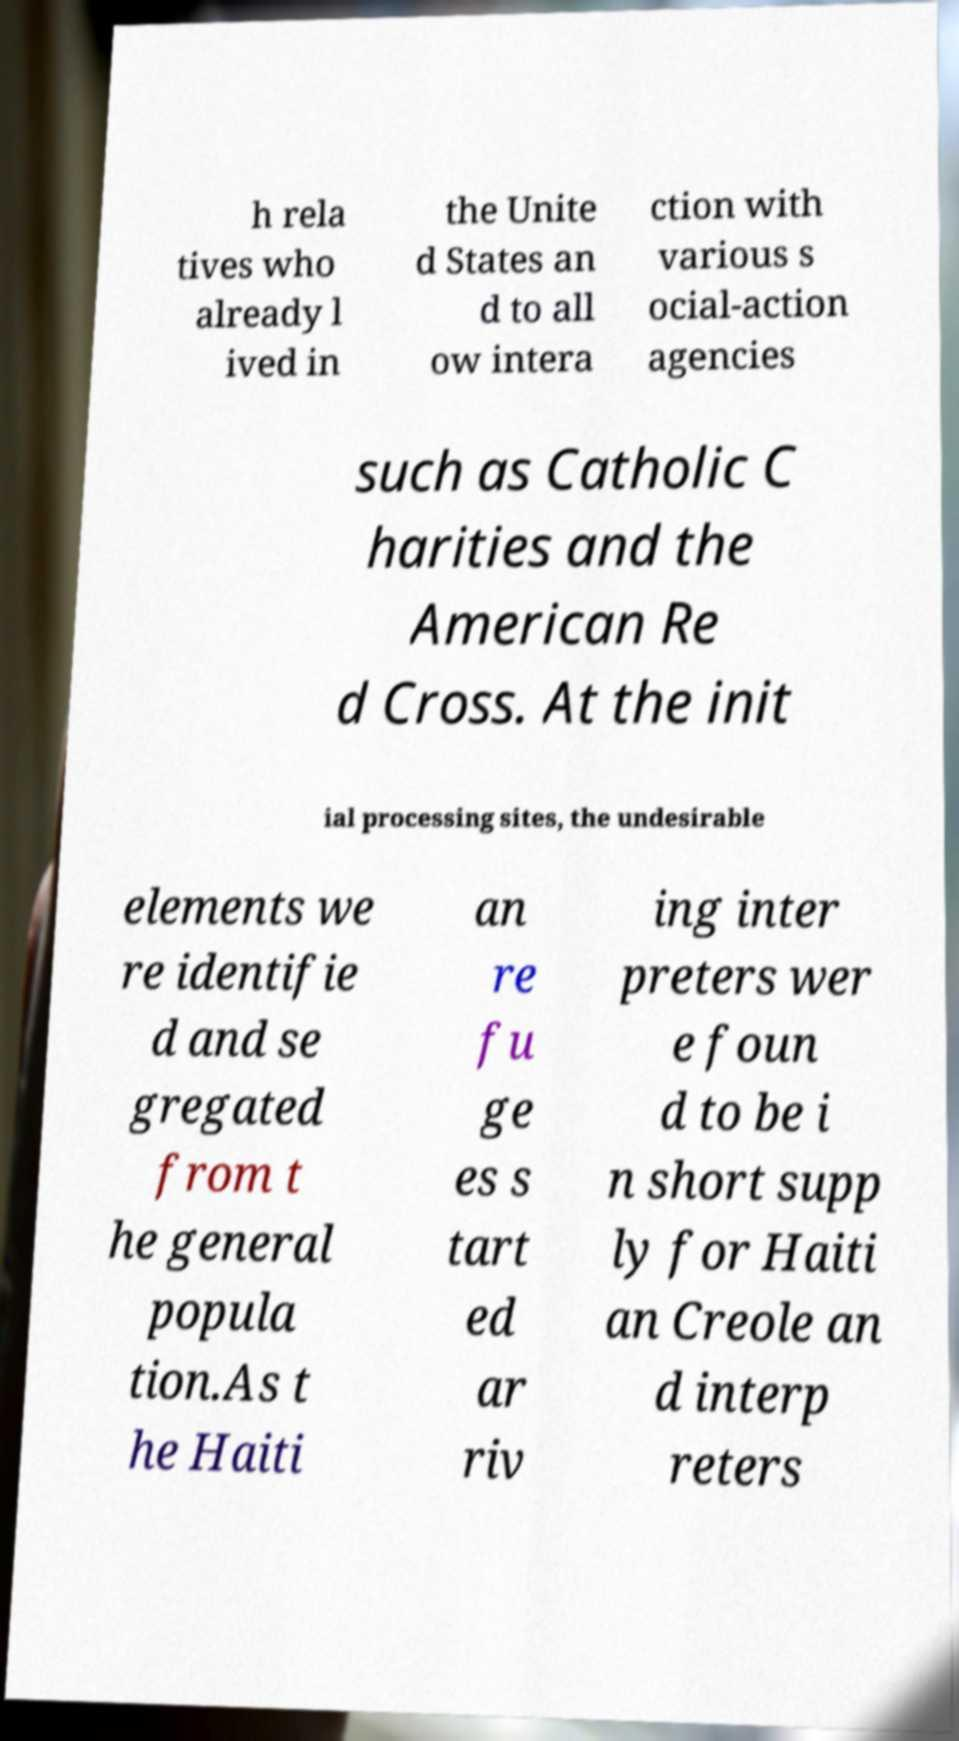Could you extract and type out the text from this image? h rela tives who already l ived in the Unite d States an d to all ow intera ction with various s ocial-action agencies such as Catholic C harities and the American Re d Cross. At the init ial processing sites, the undesirable elements we re identifie d and se gregated from t he general popula tion.As t he Haiti an re fu ge es s tart ed ar riv ing inter preters wer e foun d to be i n short supp ly for Haiti an Creole an d interp reters 